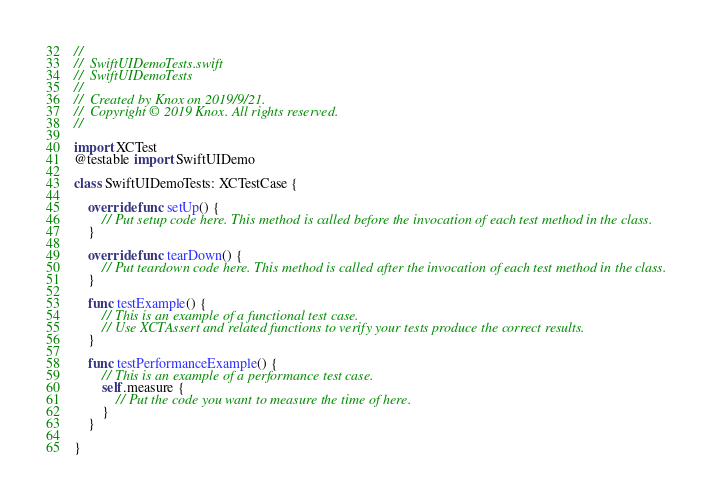Convert code to text. <code><loc_0><loc_0><loc_500><loc_500><_Swift_>//
//  SwiftUIDemoTests.swift
//  SwiftUIDemoTests
//
//  Created by Knox on 2019/9/21.
//  Copyright © 2019 Knox. All rights reserved.
//

import XCTest
@testable import SwiftUIDemo

class SwiftUIDemoTests: XCTestCase {

    override func setUp() {
        // Put setup code here. This method is called before the invocation of each test method in the class.
    }

    override func tearDown() {
        // Put teardown code here. This method is called after the invocation of each test method in the class.
    }

    func testExample() {
        // This is an example of a functional test case.
        // Use XCTAssert and related functions to verify your tests produce the correct results.
    }

    func testPerformanceExample() {
        // This is an example of a performance test case.
        self.measure {
            // Put the code you want to measure the time of here.
        }
    }

}
</code> 